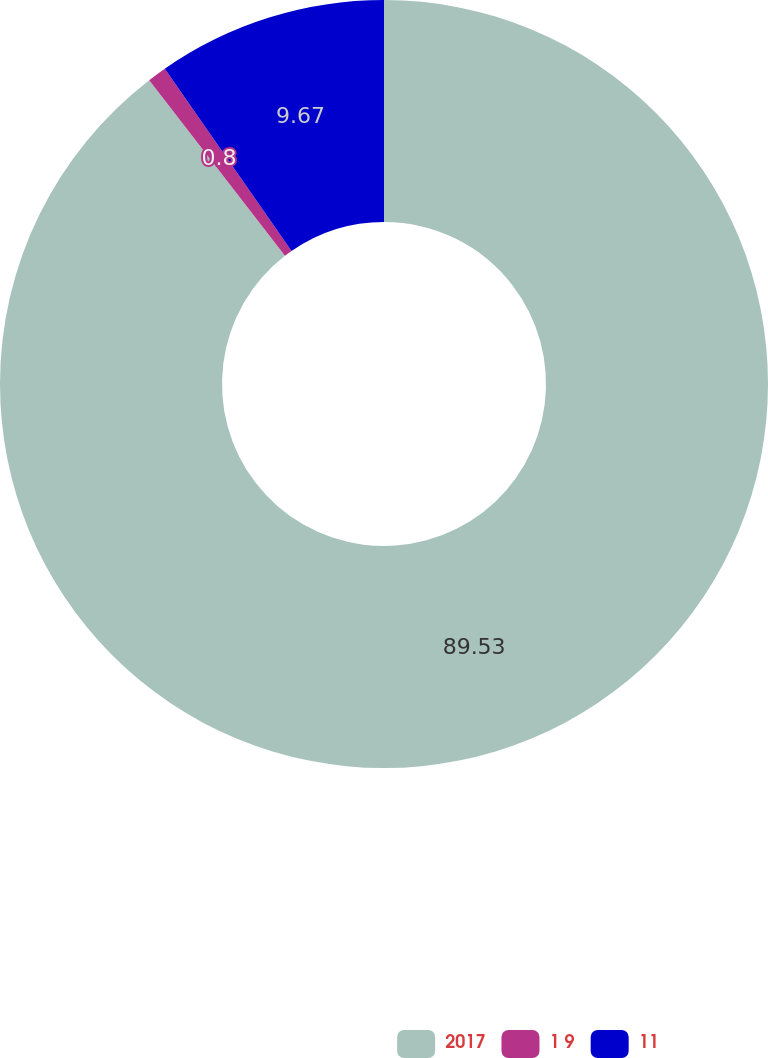<chart> <loc_0><loc_0><loc_500><loc_500><pie_chart><fcel>2017<fcel>1 9<fcel>11<nl><fcel>89.53%<fcel>0.8%<fcel>9.67%<nl></chart> 